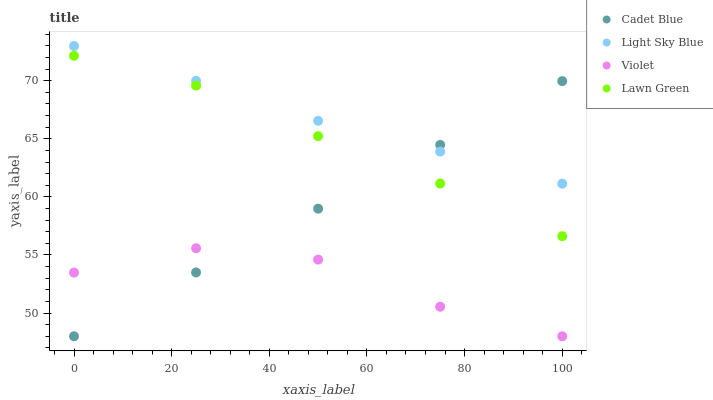Does Violet have the minimum area under the curve?
Answer yes or no. Yes. Does Light Sky Blue have the maximum area under the curve?
Answer yes or no. Yes. Does Cadet Blue have the minimum area under the curve?
Answer yes or no. No. Does Cadet Blue have the maximum area under the curve?
Answer yes or no. No. Is Cadet Blue the smoothest?
Answer yes or no. Yes. Is Violet the roughest?
Answer yes or no. Yes. Is Light Sky Blue the smoothest?
Answer yes or no. No. Is Light Sky Blue the roughest?
Answer yes or no. No. Does Cadet Blue have the lowest value?
Answer yes or no. Yes. Does Light Sky Blue have the lowest value?
Answer yes or no. No. Does Light Sky Blue have the highest value?
Answer yes or no. Yes. Does Cadet Blue have the highest value?
Answer yes or no. No. Is Violet less than Lawn Green?
Answer yes or no. Yes. Is Light Sky Blue greater than Violet?
Answer yes or no. Yes. Does Violet intersect Cadet Blue?
Answer yes or no. Yes. Is Violet less than Cadet Blue?
Answer yes or no. No. Is Violet greater than Cadet Blue?
Answer yes or no. No. Does Violet intersect Lawn Green?
Answer yes or no. No. 